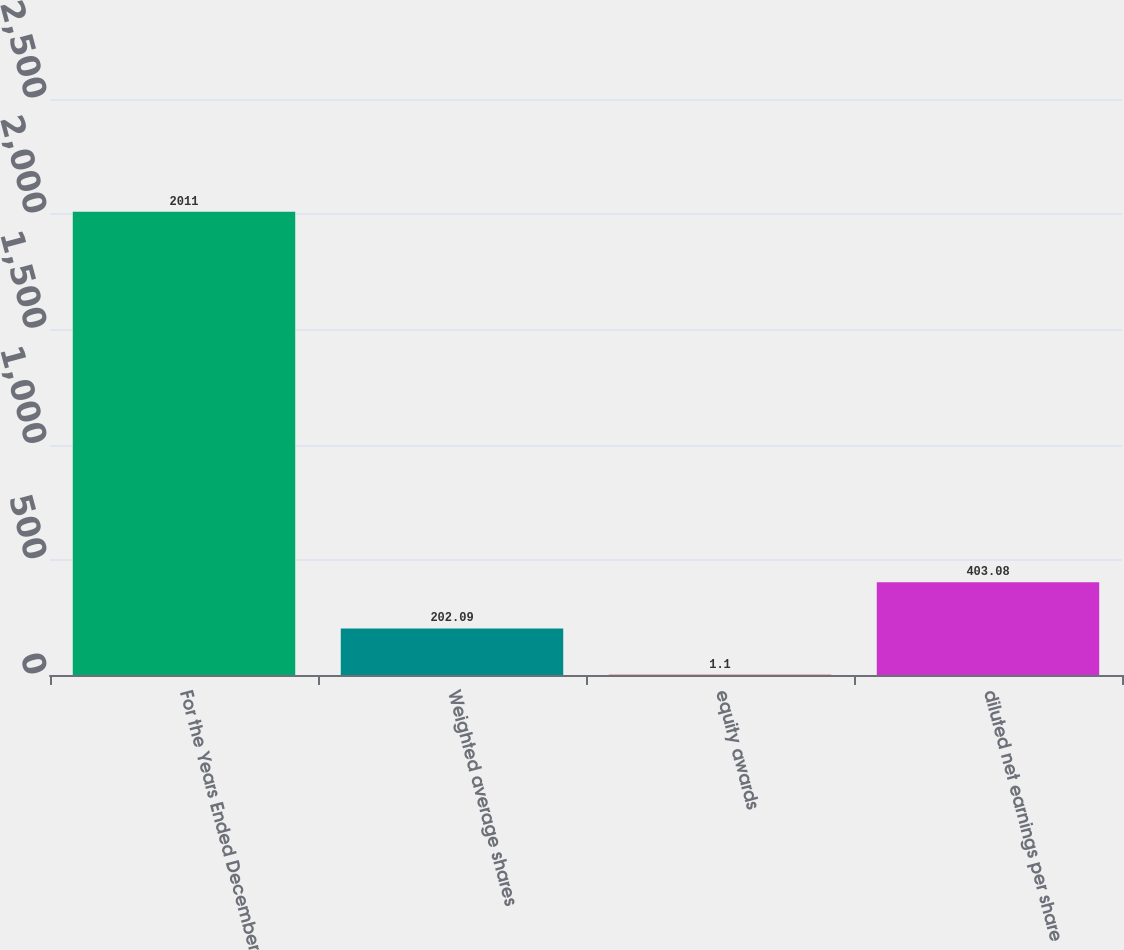<chart> <loc_0><loc_0><loc_500><loc_500><bar_chart><fcel>For the Years Ended December<fcel>Weighted average shares<fcel>equity awards<fcel>diluted net earnings per share<nl><fcel>2011<fcel>202.09<fcel>1.1<fcel>403.08<nl></chart> 